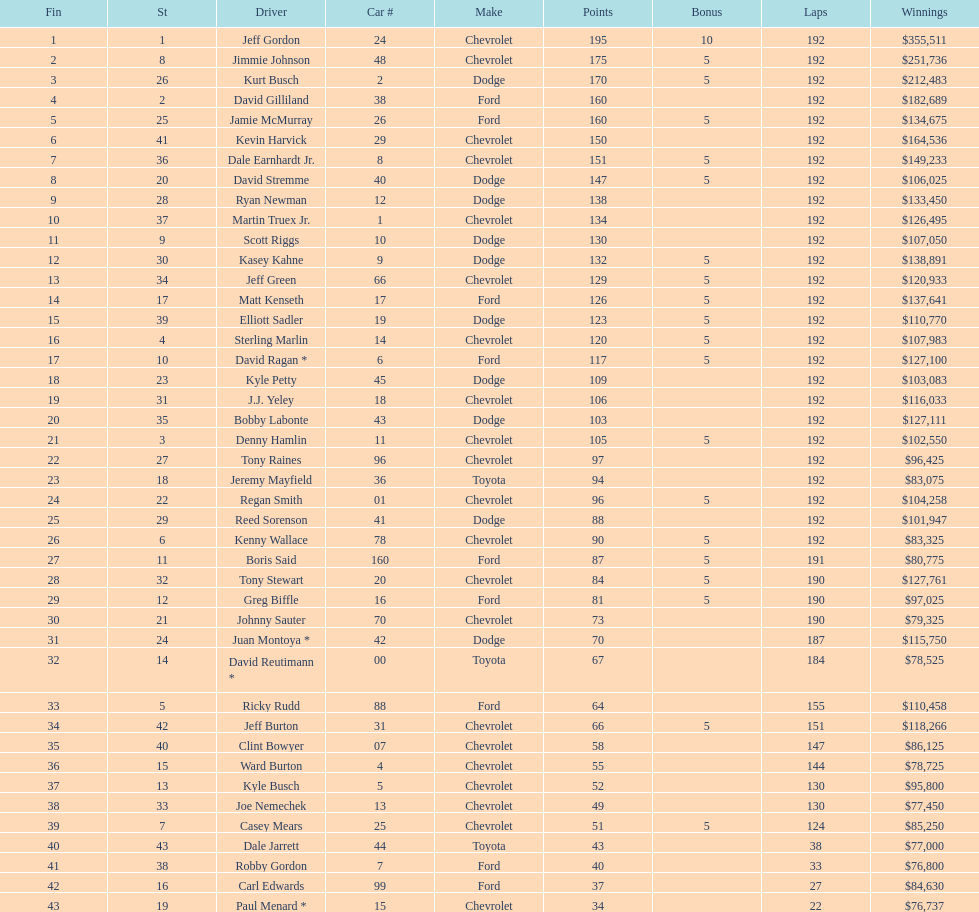Who was awarded the maximum bonus points? Jeff Gordon. Could you help me parse every detail presented in this table? {'header': ['Fin', 'St', 'Driver', 'Car #', 'Make', 'Points', 'Bonus', 'Laps', 'Winnings'], 'rows': [['1', '1', 'Jeff Gordon', '24', 'Chevrolet', '195', '10', '192', '$355,511'], ['2', '8', 'Jimmie Johnson', '48', 'Chevrolet', '175', '5', '192', '$251,736'], ['3', '26', 'Kurt Busch', '2', 'Dodge', '170', '5', '192', '$212,483'], ['4', '2', 'David Gilliland', '38', 'Ford', '160', '', '192', '$182,689'], ['5', '25', 'Jamie McMurray', '26', 'Ford', '160', '5', '192', '$134,675'], ['6', '41', 'Kevin Harvick', '29', 'Chevrolet', '150', '', '192', '$164,536'], ['7', '36', 'Dale Earnhardt Jr.', '8', 'Chevrolet', '151', '5', '192', '$149,233'], ['8', '20', 'David Stremme', '40', 'Dodge', '147', '5', '192', '$106,025'], ['9', '28', 'Ryan Newman', '12', 'Dodge', '138', '', '192', '$133,450'], ['10', '37', 'Martin Truex Jr.', '1', 'Chevrolet', '134', '', '192', '$126,495'], ['11', '9', 'Scott Riggs', '10', 'Dodge', '130', '', '192', '$107,050'], ['12', '30', 'Kasey Kahne', '9', 'Dodge', '132', '5', '192', '$138,891'], ['13', '34', 'Jeff Green', '66', 'Chevrolet', '129', '5', '192', '$120,933'], ['14', '17', 'Matt Kenseth', '17', 'Ford', '126', '5', '192', '$137,641'], ['15', '39', 'Elliott Sadler', '19', 'Dodge', '123', '5', '192', '$110,770'], ['16', '4', 'Sterling Marlin', '14', 'Chevrolet', '120', '5', '192', '$107,983'], ['17', '10', 'David Ragan *', '6', 'Ford', '117', '5', '192', '$127,100'], ['18', '23', 'Kyle Petty', '45', 'Dodge', '109', '', '192', '$103,083'], ['19', '31', 'J.J. Yeley', '18', 'Chevrolet', '106', '', '192', '$116,033'], ['20', '35', 'Bobby Labonte', '43', 'Dodge', '103', '', '192', '$127,111'], ['21', '3', 'Denny Hamlin', '11', 'Chevrolet', '105', '5', '192', '$102,550'], ['22', '27', 'Tony Raines', '96', 'Chevrolet', '97', '', '192', '$96,425'], ['23', '18', 'Jeremy Mayfield', '36', 'Toyota', '94', '', '192', '$83,075'], ['24', '22', 'Regan Smith', '01', 'Chevrolet', '96', '5', '192', '$104,258'], ['25', '29', 'Reed Sorenson', '41', 'Dodge', '88', '', '192', '$101,947'], ['26', '6', 'Kenny Wallace', '78', 'Chevrolet', '90', '5', '192', '$83,325'], ['27', '11', 'Boris Said', '160', 'Ford', '87', '5', '191', '$80,775'], ['28', '32', 'Tony Stewart', '20', 'Chevrolet', '84', '5', '190', '$127,761'], ['29', '12', 'Greg Biffle', '16', 'Ford', '81', '5', '190', '$97,025'], ['30', '21', 'Johnny Sauter', '70', 'Chevrolet', '73', '', '190', '$79,325'], ['31', '24', 'Juan Montoya *', '42', 'Dodge', '70', '', '187', '$115,750'], ['32', '14', 'David Reutimann *', '00', 'Toyota', '67', '', '184', '$78,525'], ['33', '5', 'Ricky Rudd', '88', 'Ford', '64', '', '155', '$110,458'], ['34', '42', 'Jeff Burton', '31', 'Chevrolet', '66', '5', '151', '$118,266'], ['35', '40', 'Clint Bowyer', '07', 'Chevrolet', '58', '', '147', '$86,125'], ['36', '15', 'Ward Burton', '4', 'Chevrolet', '55', '', '144', '$78,725'], ['37', '13', 'Kyle Busch', '5', 'Chevrolet', '52', '', '130', '$95,800'], ['38', '33', 'Joe Nemechek', '13', 'Chevrolet', '49', '', '130', '$77,450'], ['39', '7', 'Casey Mears', '25', 'Chevrolet', '51', '5', '124', '$85,250'], ['40', '43', 'Dale Jarrett', '44', 'Toyota', '43', '', '38', '$77,000'], ['41', '38', 'Robby Gordon', '7', 'Ford', '40', '', '33', '$76,800'], ['42', '16', 'Carl Edwards', '99', 'Ford', '37', '', '27', '$84,630'], ['43', '19', 'Paul Menard *', '15', 'Chevrolet', '34', '', '22', '$76,737']]} 